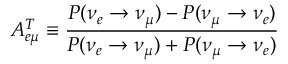<formula> <loc_0><loc_0><loc_500><loc_500>A _ { e \mu } ^ { T } \equiv \frac { P ( \nu _ { e } \rightarrow \nu _ { \mu } ) - P ( \nu _ { \mu } \rightarrow \nu _ { e } ) } { P ( \nu _ { e } \rightarrow \nu _ { \mu } ) + P ( \nu _ { \mu } \rightarrow \nu _ { e } ) } \,</formula> 